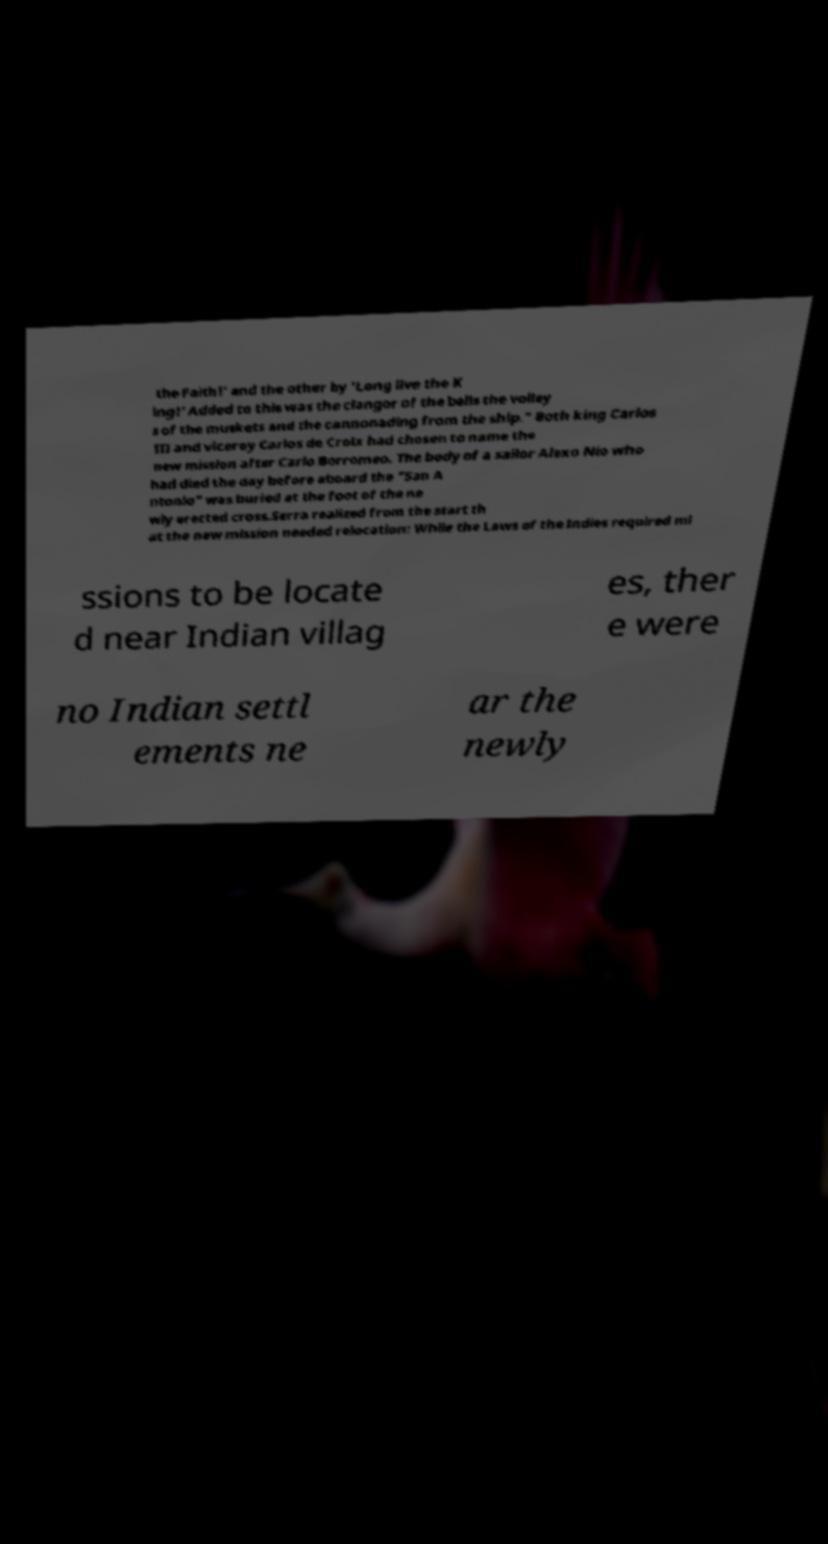Could you extract and type out the text from this image? the Faith!' and the other by 'Long live the K ing!' Added to this was the clangor of the bells the volley s of the muskets and the cannonading from the ship." Both king Carlos III and viceroy Carlos de Croix had chosen to name the new mission after Carlo Borromeo. The body of a sailor Alexo Nio who had died the day before aboard the "San A ntonio" was buried at the foot of the ne wly erected cross.Serra realized from the start th at the new mission needed relocation: While the Laws of the Indies required mi ssions to be locate d near Indian villag es, ther e were no Indian settl ements ne ar the newly 